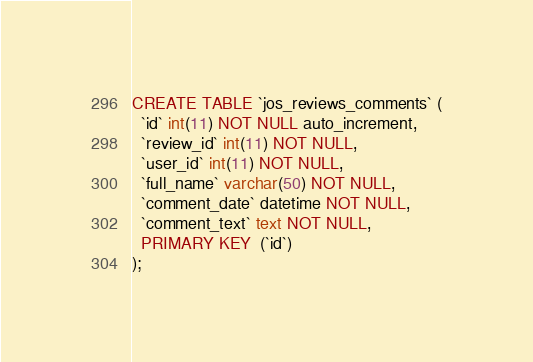Convert code to text. <code><loc_0><loc_0><loc_500><loc_500><_SQL_>CREATE TABLE `jos_reviews_comments` (
  `id` int(11) NOT NULL auto_increment,
  `review_id` int(11) NOT NULL,
  `user_id` int(11) NOT NULL,
  `full_name` varchar(50) NOT NULL,
  `comment_date` datetime NOT NULL,
  `comment_text` text NOT NULL,
  PRIMARY KEY  (`id`)
);</code> 